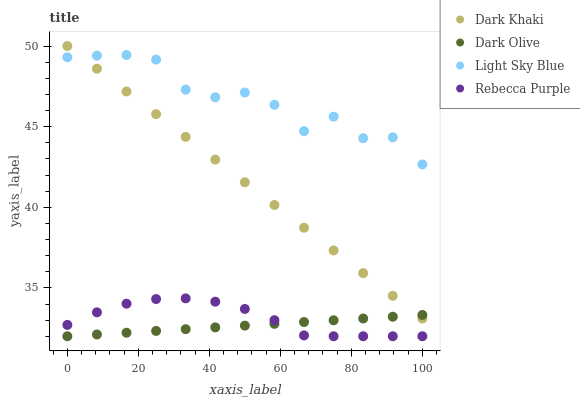Does Dark Olive have the minimum area under the curve?
Answer yes or no. Yes. Does Light Sky Blue have the maximum area under the curve?
Answer yes or no. Yes. Does Rebecca Purple have the minimum area under the curve?
Answer yes or no. No. Does Rebecca Purple have the maximum area under the curve?
Answer yes or no. No. Is Dark Olive the smoothest?
Answer yes or no. Yes. Is Light Sky Blue the roughest?
Answer yes or no. Yes. Is Rebecca Purple the smoothest?
Answer yes or no. No. Is Rebecca Purple the roughest?
Answer yes or no. No. Does Dark Olive have the lowest value?
Answer yes or no. Yes. Does Light Sky Blue have the lowest value?
Answer yes or no. No. Does Dark Khaki have the highest value?
Answer yes or no. Yes. Does Rebecca Purple have the highest value?
Answer yes or no. No. Is Dark Olive less than Light Sky Blue?
Answer yes or no. Yes. Is Light Sky Blue greater than Dark Olive?
Answer yes or no. Yes. Does Dark Olive intersect Rebecca Purple?
Answer yes or no. Yes. Is Dark Olive less than Rebecca Purple?
Answer yes or no. No. Is Dark Olive greater than Rebecca Purple?
Answer yes or no. No. Does Dark Olive intersect Light Sky Blue?
Answer yes or no. No. 